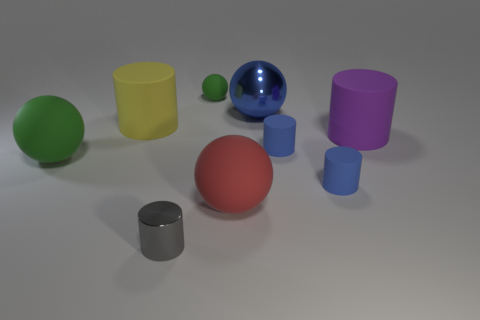Is there any object that seems out of place or different from the rest? While most objects have a polished finish, one small green sphere stands out due to its matte finish, which doesn't reflect light in the same way the other objects do. This gives it a distinct appearance when compared to the surrounding glossy objects. 